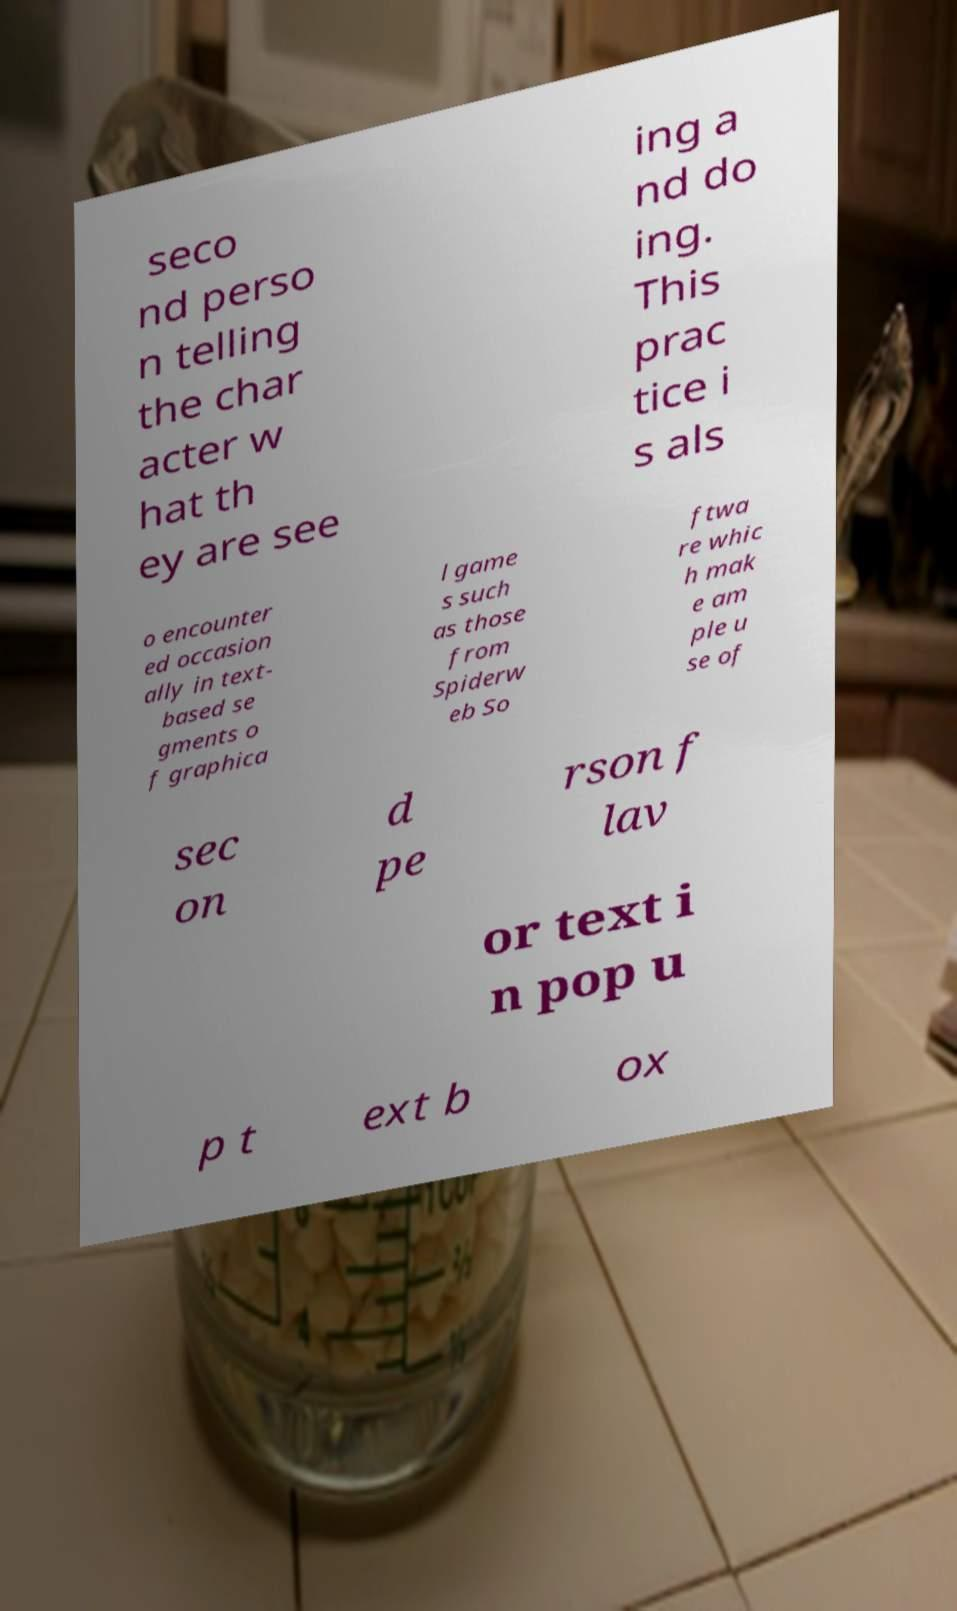Please identify and transcribe the text found in this image. seco nd perso n telling the char acter w hat th ey are see ing a nd do ing. This prac tice i s als o encounter ed occasion ally in text- based se gments o f graphica l game s such as those from Spiderw eb So ftwa re whic h mak e am ple u se of sec on d pe rson f lav or text i n pop u p t ext b ox 